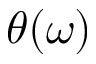Convert formula to latex. <formula><loc_0><loc_0><loc_500><loc_500>\theta ( \omega )</formula> 